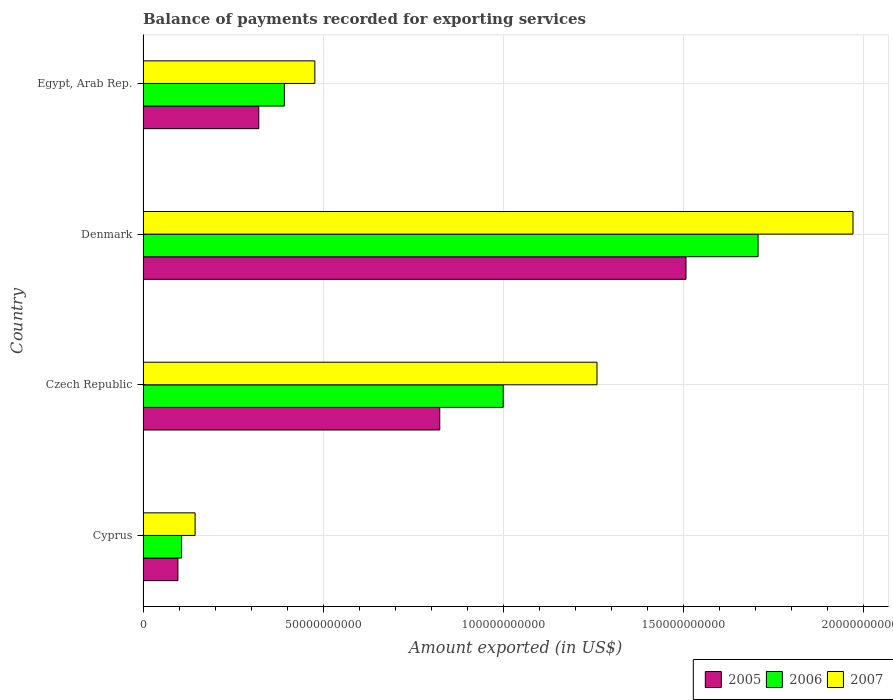How many different coloured bars are there?
Your answer should be compact. 3. How many groups of bars are there?
Provide a succinct answer. 4. What is the label of the 2nd group of bars from the top?
Your answer should be compact. Denmark. What is the amount exported in 2006 in Cyprus?
Your answer should be very brief. 1.07e+1. Across all countries, what is the maximum amount exported in 2005?
Make the answer very short. 1.51e+11. Across all countries, what is the minimum amount exported in 2007?
Ensure brevity in your answer.  1.44e+1. In which country was the amount exported in 2006 minimum?
Keep it short and to the point. Cyprus. What is the total amount exported in 2006 in the graph?
Keep it short and to the point. 3.21e+11. What is the difference between the amount exported in 2006 in Cyprus and that in Czech Republic?
Provide a succinct answer. -8.93e+1. What is the difference between the amount exported in 2005 in Cyprus and the amount exported in 2007 in Egypt, Arab Rep.?
Provide a succinct answer. -3.80e+1. What is the average amount exported in 2006 per country?
Offer a very short reply. 8.02e+1. What is the difference between the amount exported in 2007 and amount exported in 2005 in Egypt, Arab Rep.?
Your response must be concise. 1.56e+1. In how many countries, is the amount exported in 2006 greater than 60000000000 US$?
Offer a terse response. 2. What is the ratio of the amount exported in 2005 in Czech Republic to that in Denmark?
Keep it short and to the point. 0.55. Is the amount exported in 2005 in Denmark less than that in Egypt, Arab Rep.?
Your response must be concise. No. What is the difference between the highest and the second highest amount exported in 2007?
Your answer should be very brief. 7.11e+1. What is the difference between the highest and the lowest amount exported in 2007?
Keep it short and to the point. 1.83e+11. In how many countries, is the amount exported in 2005 greater than the average amount exported in 2005 taken over all countries?
Provide a short and direct response. 2. Is the sum of the amount exported in 2007 in Cyprus and Egypt, Arab Rep. greater than the maximum amount exported in 2006 across all countries?
Ensure brevity in your answer.  No. What does the 2nd bar from the top in Denmark represents?
Your response must be concise. 2006. How many bars are there?
Make the answer very short. 12. Are all the bars in the graph horizontal?
Your answer should be very brief. Yes. What is the difference between two consecutive major ticks on the X-axis?
Ensure brevity in your answer.  5.00e+1. Are the values on the major ticks of X-axis written in scientific E-notation?
Offer a very short reply. No. Does the graph contain any zero values?
Provide a succinct answer. No. Does the graph contain grids?
Provide a succinct answer. Yes. Where does the legend appear in the graph?
Your answer should be compact. Bottom right. How are the legend labels stacked?
Your response must be concise. Horizontal. What is the title of the graph?
Keep it short and to the point. Balance of payments recorded for exporting services. What is the label or title of the X-axis?
Offer a very short reply. Amount exported (in US$). What is the Amount exported (in US$) of 2005 in Cyprus?
Offer a very short reply. 9.68e+09. What is the Amount exported (in US$) in 2006 in Cyprus?
Provide a succinct answer. 1.07e+1. What is the Amount exported (in US$) in 2007 in Cyprus?
Your response must be concise. 1.44e+1. What is the Amount exported (in US$) in 2005 in Czech Republic?
Give a very brief answer. 8.24e+1. What is the Amount exported (in US$) in 2006 in Czech Republic?
Your answer should be compact. 1.00e+11. What is the Amount exported (in US$) in 2007 in Czech Republic?
Keep it short and to the point. 1.26e+11. What is the Amount exported (in US$) in 2005 in Denmark?
Your answer should be very brief. 1.51e+11. What is the Amount exported (in US$) in 2006 in Denmark?
Your response must be concise. 1.71e+11. What is the Amount exported (in US$) of 2007 in Denmark?
Your answer should be compact. 1.97e+11. What is the Amount exported (in US$) in 2005 in Egypt, Arab Rep.?
Provide a succinct answer. 3.21e+1. What is the Amount exported (in US$) of 2006 in Egypt, Arab Rep.?
Offer a terse response. 3.92e+1. What is the Amount exported (in US$) in 2007 in Egypt, Arab Rep.?
Offer a terse response. 4.77e+1. Across all countries, what is the maximum Amount exported (in US$) in 2005?
Ensure brevity in your answer.  1.51e+11. Across all countries, what is the maximum Amount exported (in US$) of 2006?
Offer a terse response. 1.71e+11. Across all countries, what is the maximum Amount exported (in US$) in 2007?
Provide a short and direct response. 1.97e+11. Across all countries, what is the minimum Amount exported (in US$) of 2005?
Ensure brevity in your answer.  9.68e+09. Across all countries, what is the minimum Amount exported (in US$) of 2006?
Provide a short and direct response. 1.07e+1. Across all countries, what is the minimum Amount exported (in US$) in 2007?
Offer a very short reply. 1.44e+1. What is the total Amount exported (in US$) in 2005 in the graph?
Your answer should be compact. 2.75e+11. What is the total Amount exported (in US$) in 2006 in the graph?
Keep it short and to the point. 3.21e+11. What is the total Amount exported (in US$) of 2007 in the graph?
Provide a succinct answer. 3.85e+11. What is the difference between the Amount exported (in US$) in 2005 in Cyprus and that in Czech Republic?
Give a very brief answer. -7.27e+1. What is the difference between the Amount exported (in US$) in 2006 in Cyprus and that in Czech Republic?
Your response must be concise. -8.93e+1. What is the difference between the Amount exported (in US$) in 2007 in Cyprus and that in Czech Republic?
Your response must be concise. -1.12e+11. What is the difference between the Amount exported (in US$) of 2005 in Cyprus and that in Denmark?
Give a very brief answer. -1.41e+11. What is the difference between the Amount exported (in US$) in 2006 in Cyprus and that in Denmark?
Provide a succinct answer. -1.60e+11. What is the difference between the Amount exported (in US$) in 2007 in Cyprus and that in Denmark?
Provide a short and direct response. -1.83e+11. What is the difference between the Amount exported (in US$) of 2005 in Cyprus and that in Egypt, Arab Rep.?
Make the answer very short. -2.25e+1. What is the difference between the Amount exported (in US$) of 2006 in Cyprus and that in Egypt, Arab Rep.?
Provide a short and direct response. -2.85e+1. What is the difference between the Amount exported (in US$) in 2007 in Cyprus and that in Egypt, Arab Rep.?
Offer a terse response. -3.33e+1. What is the difference between the Amount exported (in US$) in 2005 in Czech Republic and that in Denmark?
Provide a short and direct response. -6.84e+1. What is the difference between the Amount exported (in US$) of 2006 in Czech Republic and that in Denmark?
Offer a terse response. -7.08e+1. What is the difference between the Amount exported (in US$) of 2007 in Czech Republic and that in Denmark?
Ensure brevity in your answer.  -7.11e+1. What is the difference between the Amount exported (in US$) of 2005 in Czech Republic and that in Egypt, Arab Rep.?
Make the answer very short. 5.03e+1. What is the difference between the Amount exported (in US$) in 2006 in Czech Republic and that in Egypt, Arab Rep.?
Offer a very short reply. 6.08e+1. What is the difference between the Amount exported (in US$) in 2007 in Czech Republic and that in Egypt, Arab Rep.?
Offer a very short reply. 7.84e+1. What is the difference between the Amount exported (in US$) in 2005 in Denmark and that in Egypt, Arab Rep.?
Provide a succinct answer. 1.19e+11. What is the difference between the Amount exported (in US$) in 2006 in Denmark and that in Egypt, Arab Rep.?
Make the answer very short. 1.32e+11. What is the difference between the Amount exported (in US$) of 2007 in Denmark and that in Egypt, Arab Rep.?
Provide a succinct answer. 1.49e+11. What is the difference between the Amount exported (in US$) of 2005 in Cyprus and the Amount exported (in US$) of 2006 in Czech Republic?
Keep it short and to the point. -9.03e+1. What is the difference between the Amount exported (in US$) in 2005 in Cyprus and the Amount exported (in US$) in 2007 in Czech Republic?
Keep it short and to the point. -1.16e+11. What is the difference between the Amount exported (in US$) of 2006 in Cyprus and the Amount exported (in US$) of 2007 in Czech Republic?
Your answer should be very brief. -1.15e+11. What is the difference between the Amount exported (in US$) of 2005 in Cyprus and the Amount exported (in US$) of 2006 in Denmark?
Offer a very short reply. -1.61e+11. What is the difference between the Amount exported (in US$) of 2005 in Cyprus and the Amount exported (in US$) of 2007 in Denmark?
Make the answer very short. -1.87e+11. What is the difference between the Amount exported (in US$) in 2006 in Cyprus and the Amount exported (in US$) in 2007 in Denmark?
Offer a very short reply. -1.86e+11. What is the difference between the Amount exported (in US$) of 2005 in Cyprus and the Amount exported (in US$) of 2006 in Egypt, Arab Rep.?
Keep it short and to the point. -2.96e+1. What is the difference between the Amount exported (in US$) of 2005 in Cyprus and the Amount exported (in US$) of 2007 in Egypt, Arab Rep.?
Provide a short and direct response. -3.80e+1. What is the difference between the Amount exported (in US$) in 2006 in Cyprus and the Amount exported (in US$) in 2007 in Egypt, Arab Rep.?
Your answer should be very brief. -3.70e+1. What is the difference between the Amount exported (in US$) of 2005 in Czech Republic and the Amount exported (in US$) of 2006 in Denmark?
Your answer should be compact. -8.84e+1. What is the difference between the Amount exported (in US$) of 2005 in Czech Republic and the Amount exported (in US$) of 2007 in Denmark?
Offer a terse response. -1.15e+11. What is the difference between the Amount exported (in US$) in 2006 in Czech Republic and the Amount exported (in US$) in 2007 in Denmark?
Your response must be concise. -9.71e+1. What is the difference between the Amount exported (in US$) of 2005 in Czech Republic and the Amount exported (in US$) of 2006 in Egypt, Arab Rep.?
Keep it short and to the point. 4.32e+1. What is the difference between the Amount exported (in US$) in 2005 in Czech Republic and the Amount exported (in US$) in 2007 in Egypt, Arab Rep.?
Provide a succinct answer. 3.47e+1. What is the difference between the Amount exported (in US$) in 2006 in Czech Republic and the Amount exported (in US$) in 2007 in Egypt, Arab Rep.?
Provide a short and direct response. 5.23e+1. What is the difference between the Amount exported (in US$) in 2005 in Denmark and the Amount exported (in US$) in 2006 in Egypt, Arab Rep.?
Provide a succinct answer. 1.12e+11. What is the difference between the Amount exported (in US$) of 2005 in Denmark and the Amount exported (in US$) of 2007 in Egypt, Arab Rep.?
Make the answer very short. 1.03e+11. What is the difference between the Amount exported (in US$) of 2006 in Denmark and the Amount exported (in US$) of 2007 in Egypt, Arab Rep.?
Your answer should be very brief. 1.23e+11. What is the average Amount exported (in US$) in 2005 per country?
Your answer should be very brief. 6.88e+1. What is the average Amount exported (in US$) in 2006 per country?
Provide a short and direct response. 8.02e+1. What is the average Amount exported (in US$) of 2007 per country?
Provide a succinct answer. 9.63e+1. What is the difference between the Amount exported (in US$) of 2005 and Amount exported (in US$) of 2006 in Cyprus?
Keep it short and to the point. -1.01e+09. What is the difference between the Amount exported (in US$) in 2005 and Amount exported (in US$) in 2007 in Cyprus?
Make the answer very short. -4.77e+09. What is the difference between the Amount exported (in US$) of 2006 and Amount exported (in US$) of 2007 in Cyprus?
Offer a very short reply. -3.76e+09. What is the difference between the Amount exported (in US$) of 2005 and Amount exported (in US$) of 2006 in Czech Republic?
Your response must be concise. -1.76e+1. What is the difference between the Amount exported (in US$) in 2005 and Amount exported (in US$) in 2007 in Czech Republic?
Make the answer very short. -4.37e+1. What is the difference between the Amount exported (in US$) of 2006 and Amount exported (in US$) of 2007 in Czech Republic?
Your answer should be very brief. -2.60e+1. What is the difference between the Amount exported (in US$) of 2005 and Amount exported (in US$) of 2006 in Denmark?
Your answer should be compact. -2.00e+1. What is the difference between the Amount exported (in US$) of 2005 and Amount exported (in US$) of 2007 in Denmark?
Make the answer very short. -4.64e+1. What is the difference between the Amount exported (in US$) in 2006 and Amount exported (in US$) in 2007 in Denmark?
Offer a terse response. -2.64e+1. What is the difference between the Amount exported (in US$) in 2005 and Amount exported (in US$) in 2006 in Egypt, Arab Rep.?
Give a very brief answer. -7.10e+09. What is the difference between the Amount exported (in US$) of 2005 and Amount exported (in US$) of 2007 in Egypt, Arab Rep.?
Your answer should be compact. -1.56e+1. What is the difference between the Amount exported (in US$) in 2006 and Amount exported (in US$) in 2007 in Egypt, Arab Rep.?
Ensure brevity in your answer.  -8.47e+09. What is the ratio of the Amount exported (in US$) of 2005 in Cyprus to that in Czech Republic?
Make the answer very short. 0.12. What is the ratio of the Amount exported (in US$) in 2006 in Cyprus to that in Czech Republic?
Your answer should be very brief. 0.11. What is the ratio of the Amount exported (in US$) in 2007 in Cyprus to that in Czech Republic?
Provide a succinct answer. 0.11. What is the ratio of the Amount exported (in US$) of 2005 in Cyprus to that in Denmark?
Make the answer very short. 0.06. What is the ratio of the Amount exported (in US$) in 2006 in Cyprus to that in Denmark?
Your answer should be compact. 0.06. What is the ratio of the Amount exported (in US$) in 2007 in Cyprus to that in Denmark?
Give a very brief answer. 0.07. What is the ratio of the Amount exported (in US$) in 2005 in Cyprus to that in Egypt, Arab Rep.?
Provide a short and direct response. 0.3. What is the ratio of the Amount exported (in US$) in 2006 in Cyprus to that in Egypt, Arab Rep.?
Your answer should be very brief. 0.27. What is the ratio of the Amount exported (in US$) of 2007 in Cyprus to that in Egypt, Arab Rep.?
Provide a short and direct response. 0.3. What is the ratio of the Amount exported (in US$) of 2005 in Czech Republic to that in Denmark?
Keep it short and to the point. 0.55. What is the ratio of the Amount exported (in US$) in 2006 in Czech Republic to that in Denmark?
Your answer should be compact. 0.59. What is the ratio of the Amount exported (in US$) in 2007 in Czech Republic to that in Denmark?
Your answer should be very brief. 0.64. What is the ratio of the Amount exported (in US$) in 2005 in Czech Republic to that in Egypt, Arab Rep.?
Ensure brevity in your answer.  2.56. What is the ratio of the Amount exported (in US$) of 2006 in Czech Republic to that in Egypt, Arab Rep.?
Provide a short and direct response. 2.55. What is the ratio of the Amount exported (in US$) of 2007 in Czech Republic to that in Egypt, Arab Rep.?
Provide a succinct answer. 2.64. What is the ratio of the Amount exported (in US$) in 2005 in Denmark to that in Egypt, Arab Rep.?
Offer a very short reply. 4.69. What is the ratio of the Amount exported (in US$) in 2006 in Denmark to that in Egypt, Arab Rep.?
Your answer should be compact. 4.35. What is the ratio of the Amount exported (in US$) in 2007 in Denmark to that in Egypt, Arab Rep.?
Give a very brief answer. 4.13. What is the difference between the highest and the second highest Amount exported (in US$) in 2005?
Offer a very short reply. 6.84e+1. What is the difference between the highest and the second highest Amount exported (in US$) in 2006?
Provide a succinct answer. 7.08e+1. What is the difference between the highest and the second highest Amount exported (in US$) of 2007?
Keep it short and to the point. 7.11e+1. What is the difference between the highest and the lowest Amount exported (in US$) of 2005?
Keep it short and to the point. 1.41e+11. What is the difference between the highest and the lowest Amount exported (in US$) in 2006?
Provide a succinct answer. 1.60e+11. What is the difference between the highest and the lowest Amount exported (in US$) in 2007?
Your answer should be very brief. 1.83e+11. 